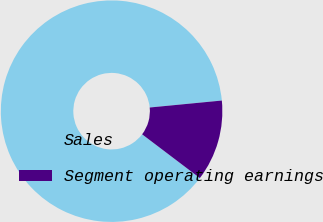<chart> <loc_0><loc_0><loc_500><loc_500><pie_chart><fcel>Sales<fcel>Segment operating earnings<nl><fcel>88.15%<fcel>11.85%<nl></chart> 